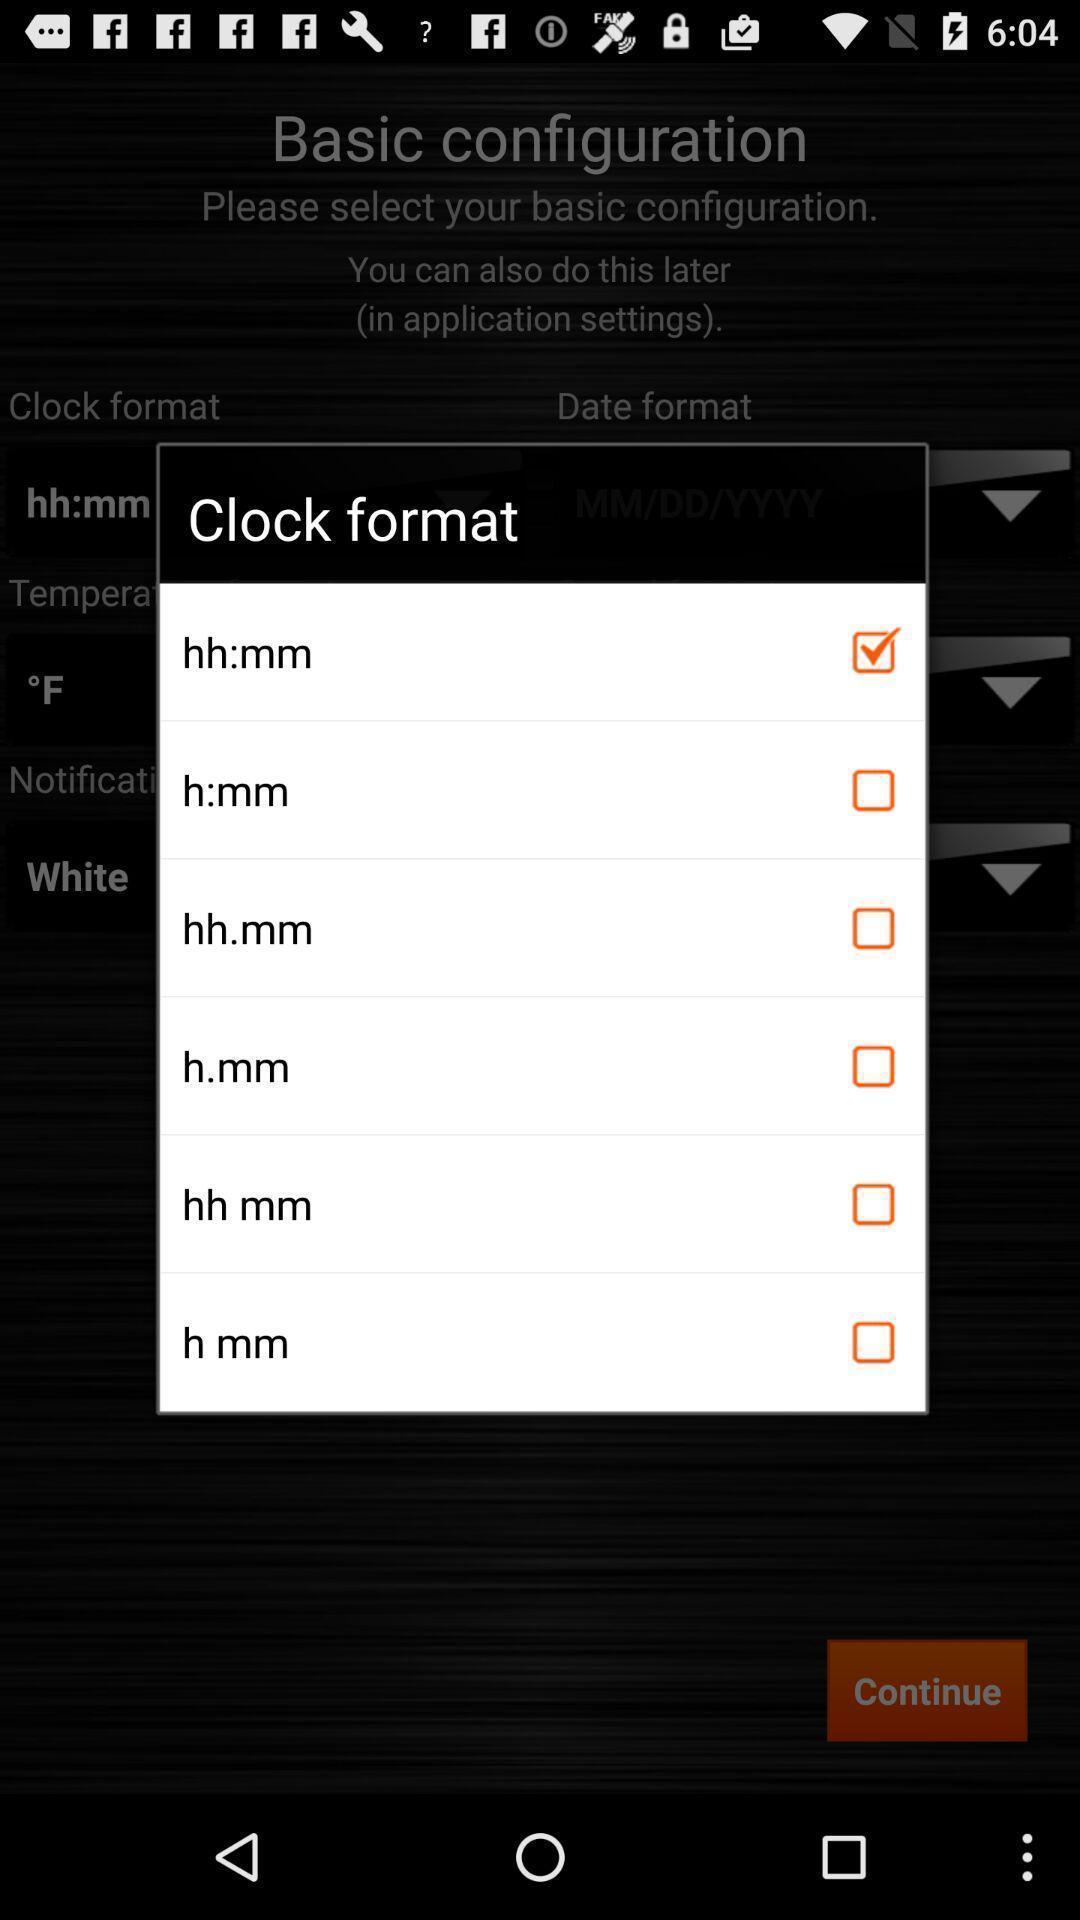Tell me what you see in this picture. Popup of list of formats for clock. 